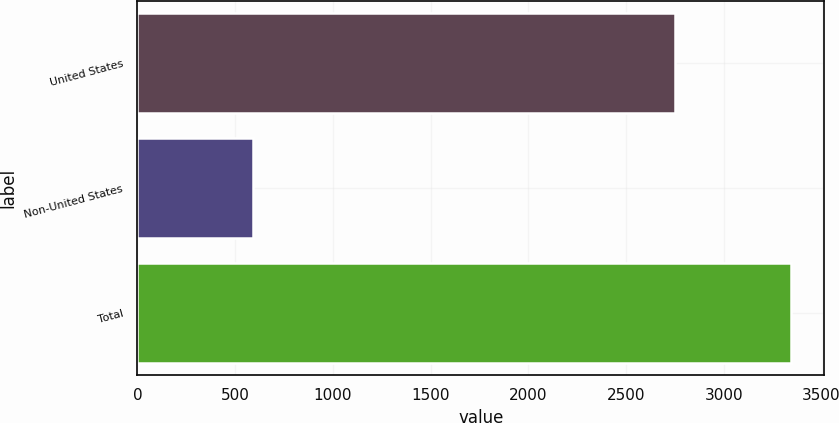Convert chart. <chart><loc_0><loc_0><loc_500><loc_500><bar_chart><fcel>United States<fcel>Non-United States<fcel>Total<nl><fcel>2752.1<fcel>593.8<fcel>3345.9<nl></chart> 